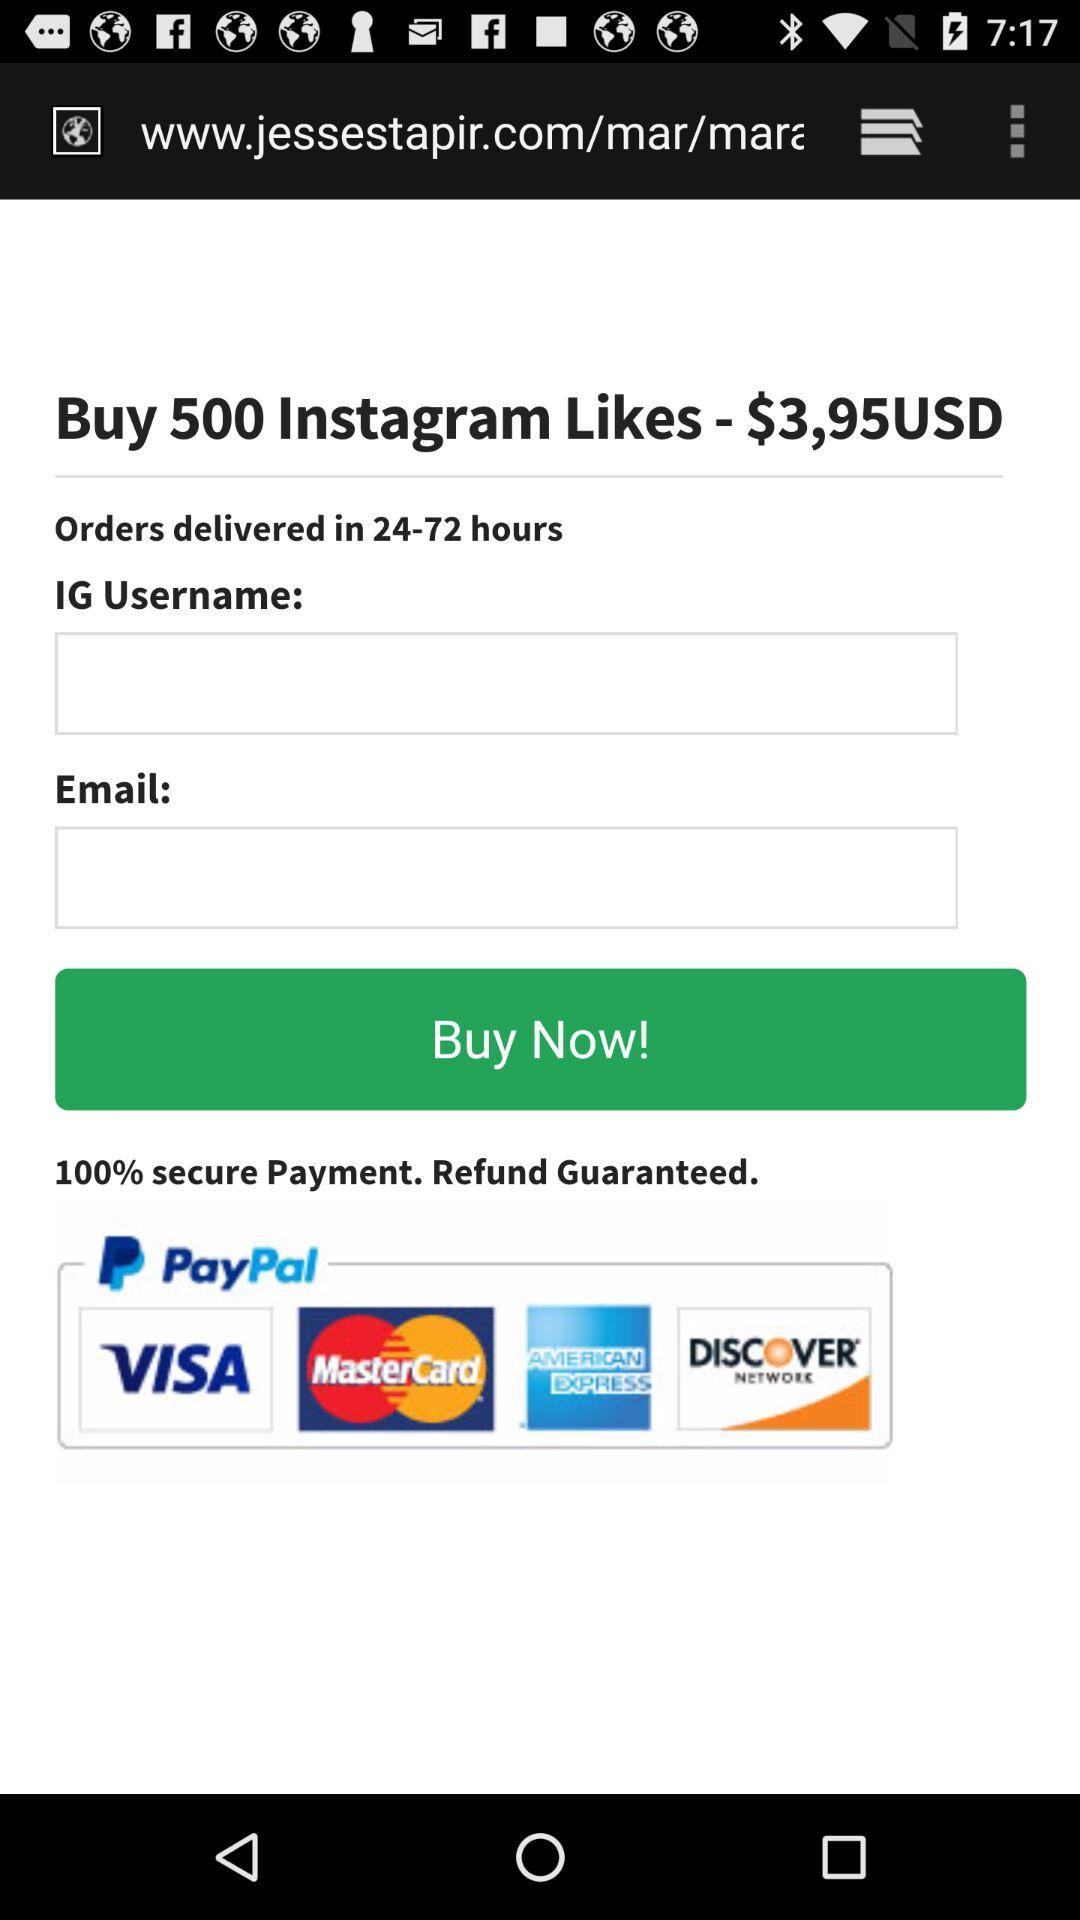What's the price of buying 500 Instagram likes? The price is $3,95USD. 